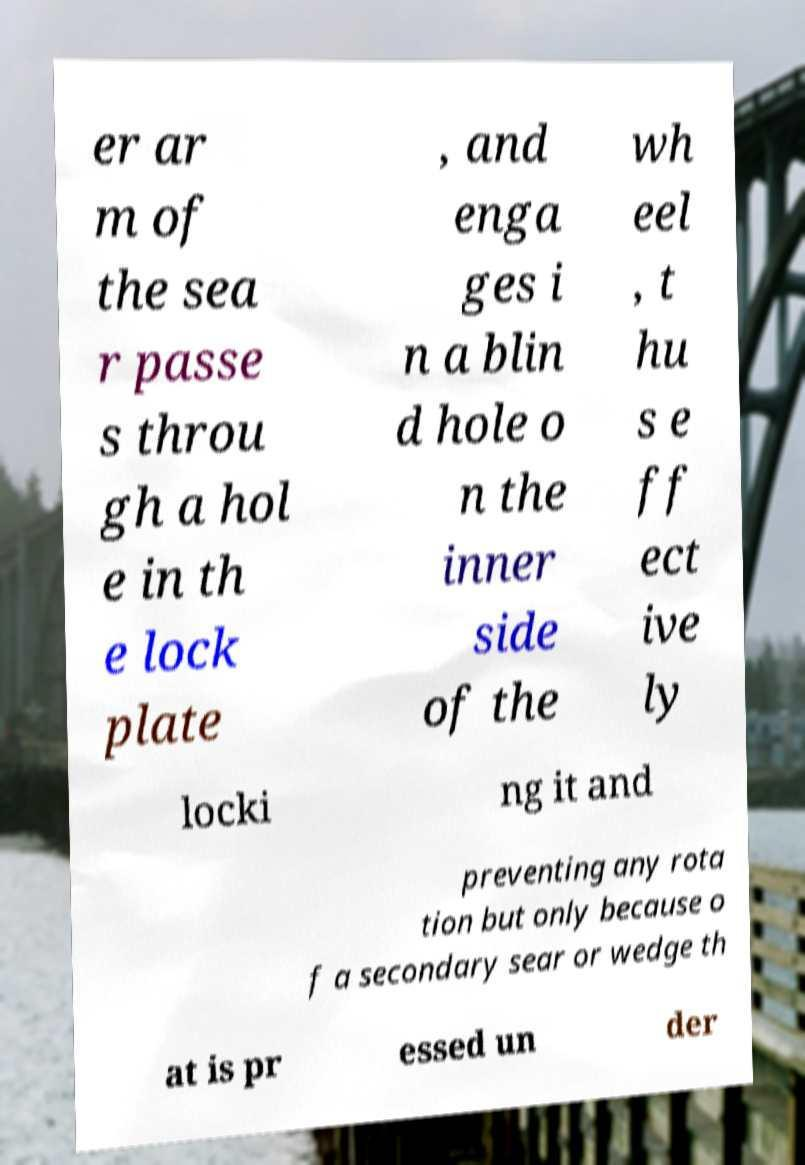Please read and relay the text visible in this image. What does it say? er ar m of the sea r passe s throu gh a hol e in th e lock plate , and enga ges i n a blin d hole o n the inner side of the wh eel , t hu s e ff ect ive ly locki ng it and preventing any rota tion but only because o f a secondary sear or wedge th at is pr essed un der 